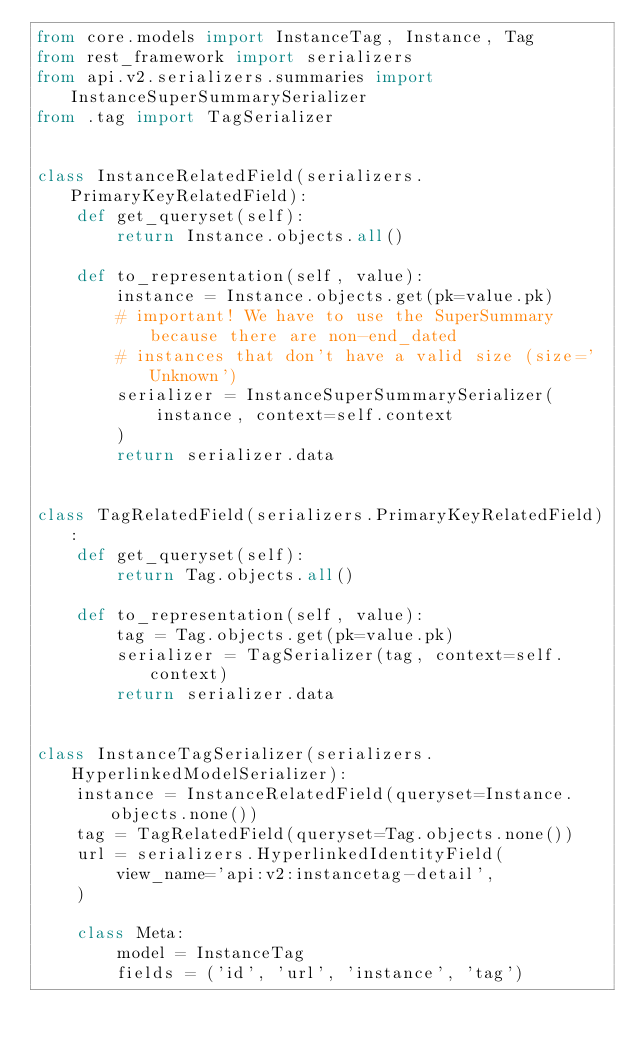Convert code to text. <code><loc_0><loc_0><loc_500><loc_500><_Python_>from core.models import InstanceTag, Instance, Tag
from rest_framework import serializers
from api.v2.serializers.summaries import InstanceSuperSummarySerializer
from .tag import TagSerializer


class InstanceRelatedField(serializers.PrimaryKeyRelatedField):
    def get_queryset(self):
        return Instance.objects.all()

    def to_representation(self, value):
        instance = Instance.objects.get(pk=value.pk)
        # important! We have to use the SuperSummary because there are non-end_dated
        # instances that don't have a valid size (size='Unknown')
        serializer = InstanceSuperSummarySerializer(
            instance, context=self.context
        )
        return serializer.data


class TagRelatedField(serializers.PrimaryKeyRelatedField):
    def get_queryset(self):
        return Tag.objects.all()

    def to_representation(self, value):
        tag = Tag.objects.get(pk=value.pk)
        serializer = TagSerializer(tag, context=self.context)
        return serializer.data


class InstanceTagSerializer(serializers.HyperlinkedModelSerializer):
    instance = InstanceRelatedField(queryset=Instance.objects.none())
    tag = TagRelatedField(queryset=Tag.objects.none())
    url = serializers.HyperlinkedIdentityField(
        view_name='api:v2:instancetag-detail',
    )

    class Meta:
        model = InstanceTag
        fields = ('id', 'url', 'instance', 'tag')
</code> 